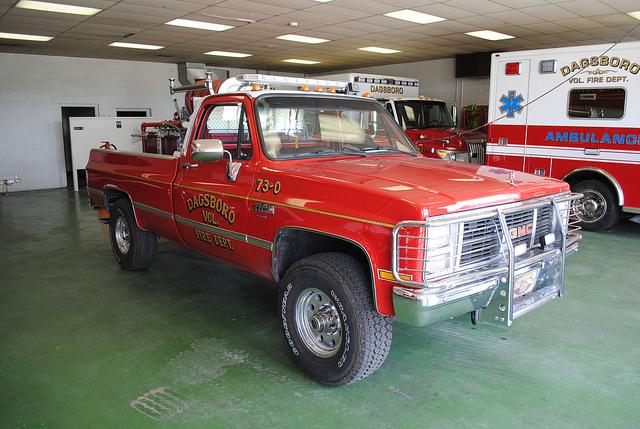Do these professionals volunteer?
Give a very brief answer. Yes. What color is the floor?
Concise answer only. Green. What type of vehicles are these?
Concise answer only. Emergency. 